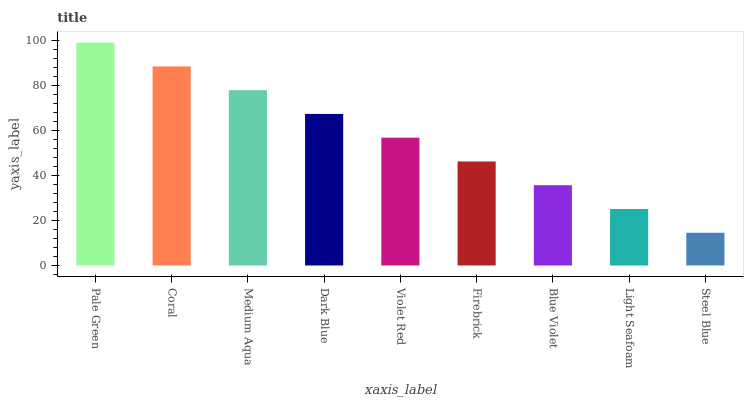Is Coral the minimum?
Answer yes or no. No. Is Coral the maximum?
Answer yes or no. No. Is Pale Green greater than Coral?
Answer yes or no. Yes. Is Coral less than Pale Green?
Answer yes or no. Yes. Is Coral greater than Pale Green?
Answer yes or no. No. Is Pale Green less than Coral?
Answer yes or no. No. Is Violet Red the high median?
Answer yes or no. Yes. Is Violet Red the low median?
Answer yes or no. Yes. Is Pale Green the high median?
Answer yes or no. No. Is Medium Aqua the low median?
Answer yes or no. No. 